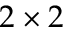<formula> <loc_0><loc_0><loc_500><loc_500>2 \times 2</formula> 